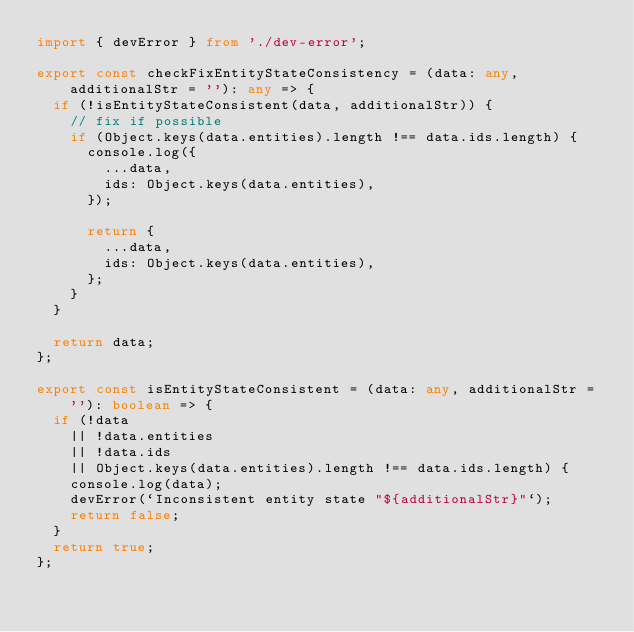Convert code to text. <code><loc_0><loc_0><loc_500><loc_500><_TypeScript_>import { devError } from './dev-error';

export const checkFixEntityStateConsistency = (data: any, additionalStr = ''): any => {
  if (!isEntityStateConsistent(data, additionalStr)) {
    // fix if possible
    if (Object.keys(data.entities).length !== data.ids.length) {
      console.log({
        ...data,
        ids: Object.keys(data.entities),
      });

      return {
        ...data,
        ids: Object.keys(data.entities),
      };
    }
  }

  return data;
};

export const isEntityStateConsistent = (data: any, additionalStr = ''): boolean => {
  if (!data
    || !data.entities
    || !data.ids
    || Object.keys(data.entities).length !== data.ids.length) {
    console.log(data);
    devError(`Inconsistent entity state "${additionalStr}"`);
    return false;
  }
  return true;
};
</code> 